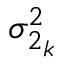<formula> <loc_0><loc_0><loc_500><loc_500>\sigma _ { 2 _ { k } } ^ { 2 }</formula> 